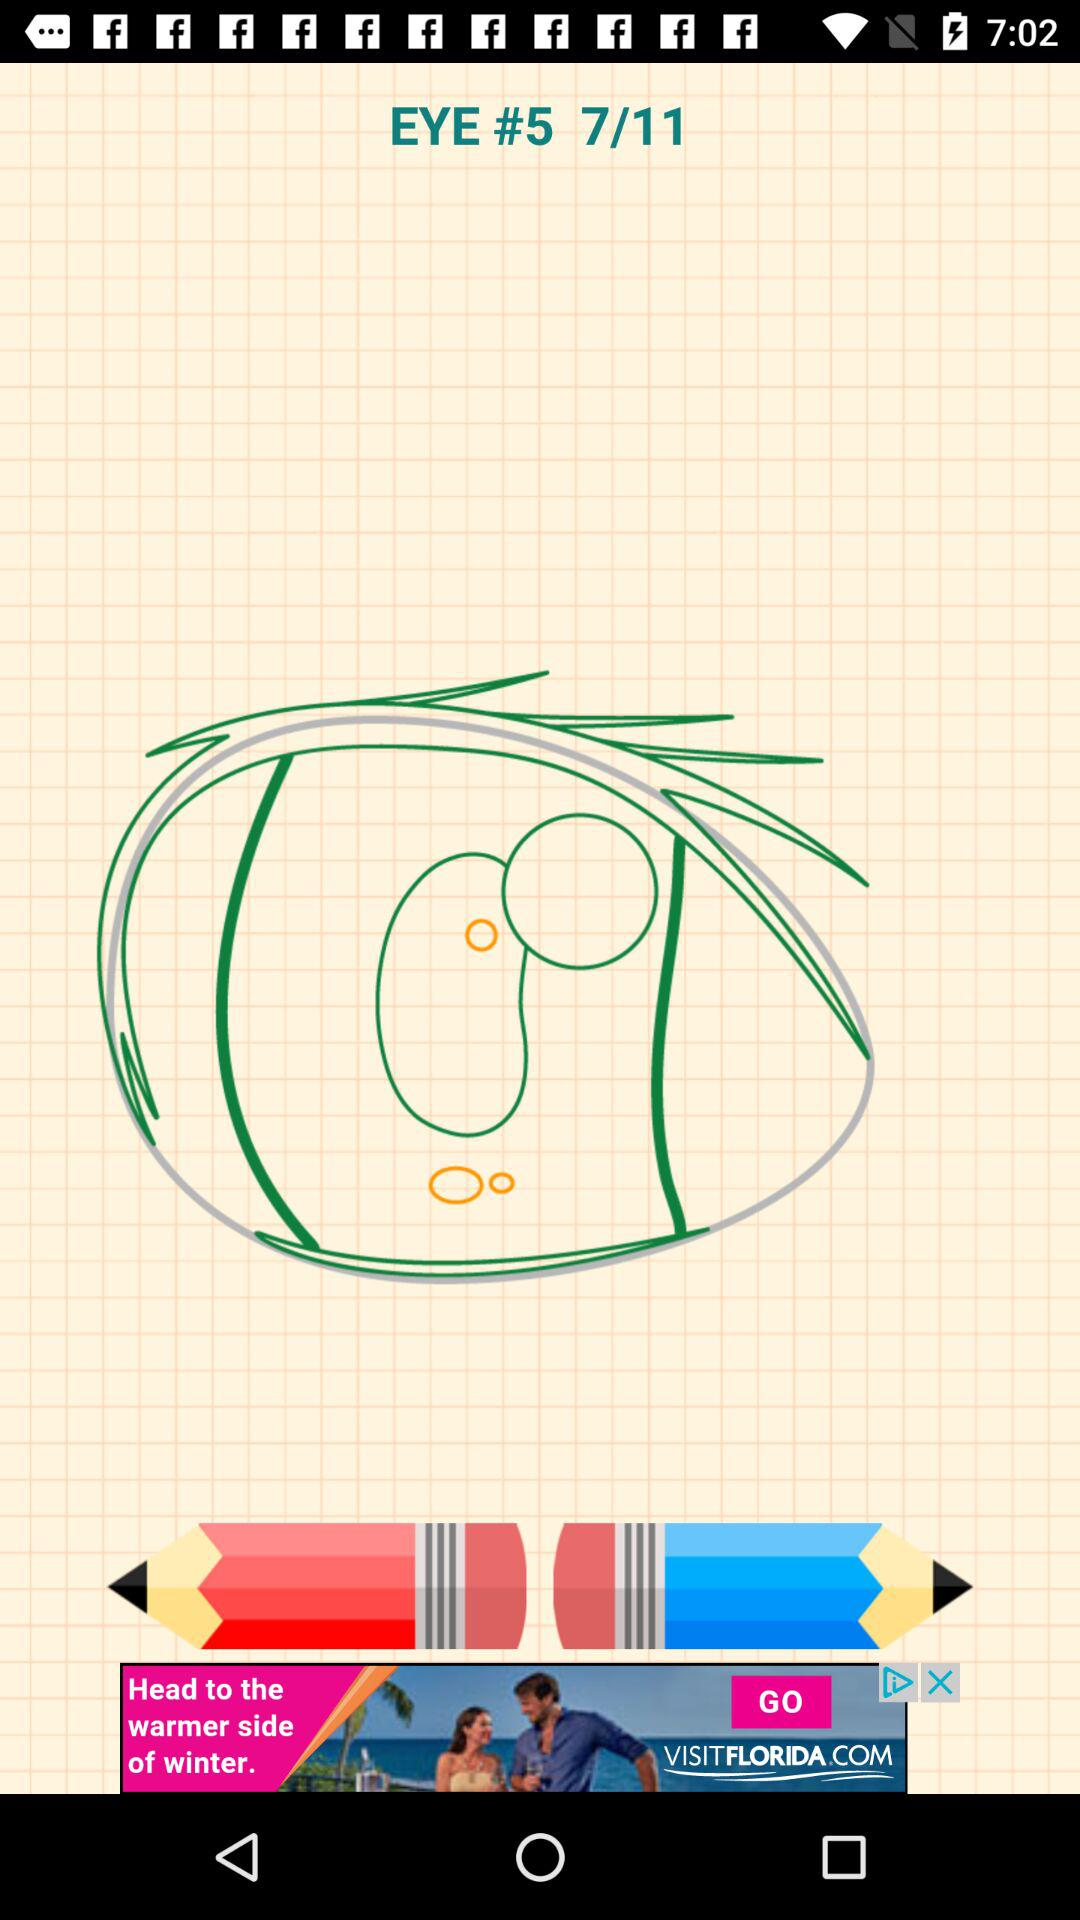How many images in total are there? There are 11 images. 